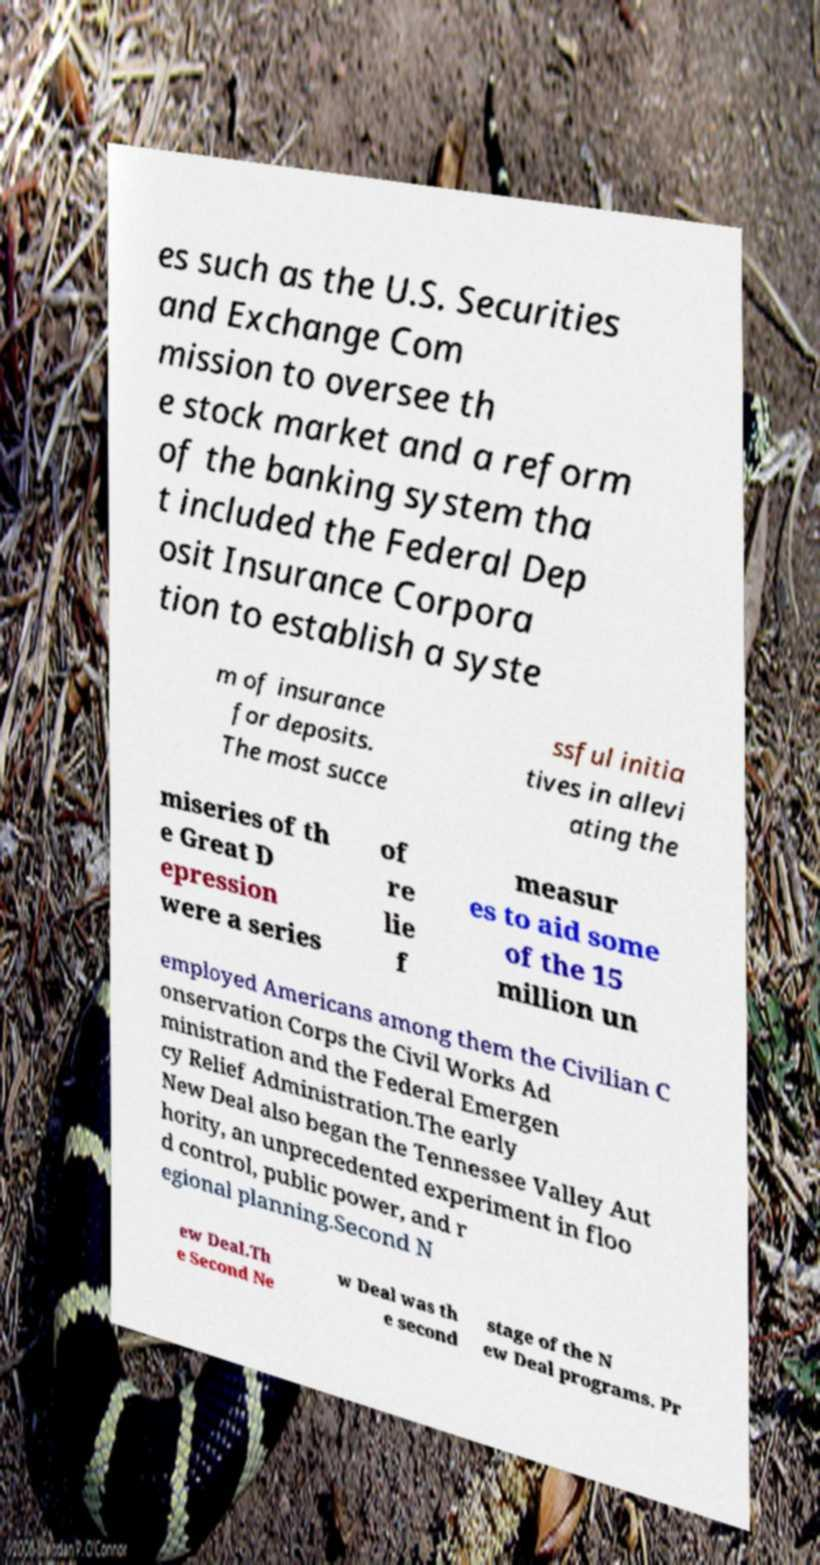Please identify and transcribe the text found in this image. es such as the U.S. Securities and Exchange Com mission to oversee th e stock market and a reform of the banking system tha t included the Federal Dep osit Insurance Corpora tion to establish a syste m of insurance for deposits. The most succe ssful initia tives in allevi ating the miseries of th e Great D epression were a series of re lie f measur es to aid some of the 15 million un employed Americans among them the Civilian C onservation Corps the Civil Works Ad ministration and the Federal Emergen cy Relief Administration.The early New Deal also began the Tennessee Valley Aut hority, an unprecedented experiment in floo d control, public power, and r egional planning.Second N ew Deal.Th e Second Ne w Deal was th e second stage of the N ew Deal programs. Pr 